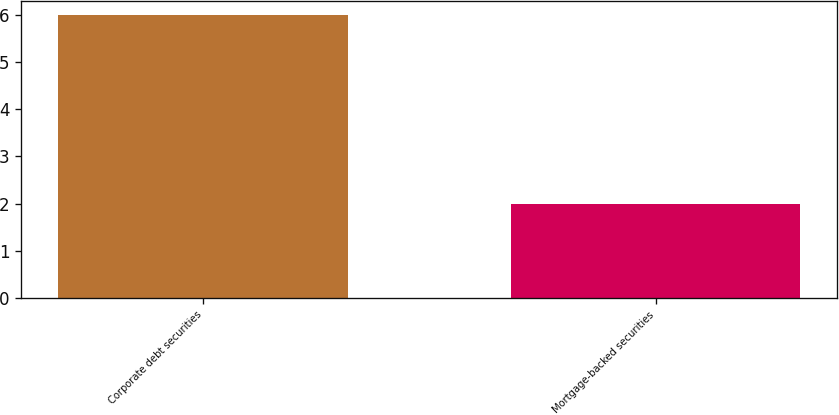<chart> <loc_0><loc_0><loc_500><loc_500><bar_chart><fcel>Corporate debt securities<fcel>Mortgage-backed securities<nl><fcel>6<fcel>2<nl></chart> 